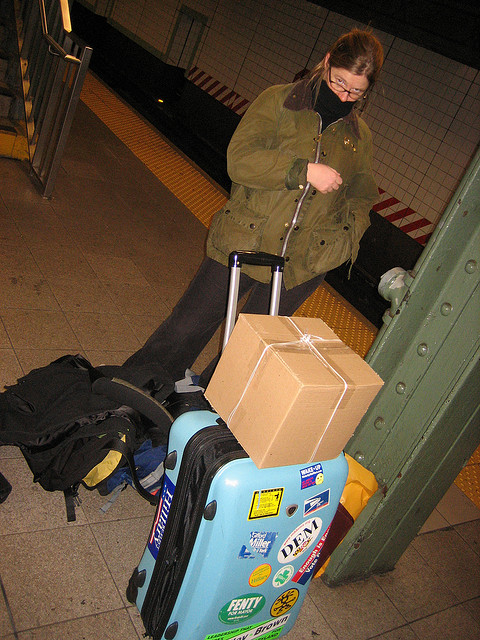Identify the text contained in this image. FENTY DEM Brown 